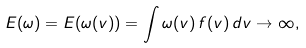Convert formula to latex. <formula><loc_0><loc_0><loc_500><loc_500>E ( \omega ) = E ( \omega ( v ) ) = \int \omega ( v ) \, f ( v ) \, d v \rightarrow \infty ,</formula> 